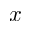Convert formula to latex. <formula><loc_0><loc_0><loc_500><loc_500>x</formula> 